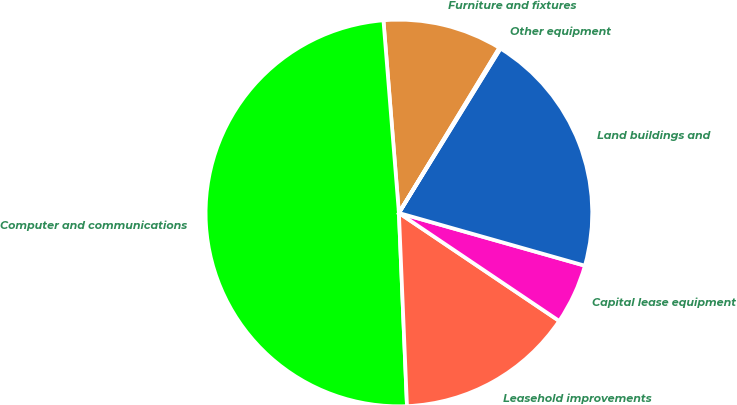Convert chart. <chart><loc_0><loc_0><loc_500><loc_500><pie_chart><fcel>Furniture and fixtures<fcel>Computer and communications<fcel>Leasehold improvements<fcel>Capital lease equipment<fcel>Land buildings and<fcel>Other equipment<nl><fcel>9.97%<fcel>49.39%<fcel>14.9%<fcel>5.04%<fcel>20.59%<fcel>0.11%<nl></chart> 